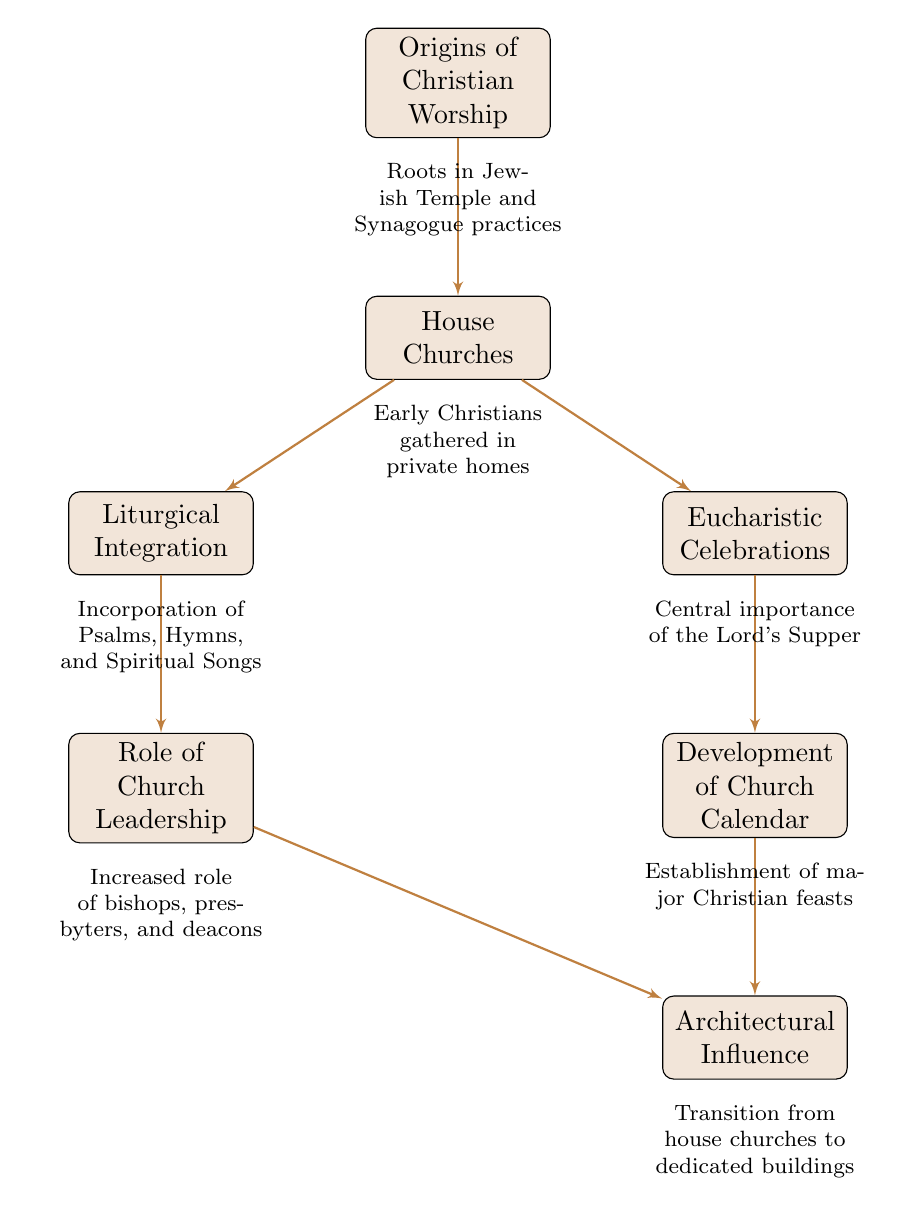What is the first node in the flow chart? The first node in the flow chart is "Origins of Christian Worship". It is the starting point that introduces the roots of Christian liturgical practices.
Answer: Origins of Christian Worship How many nodes are in the diagram? The diagram contains seven nodes, each representing a significant development in early Christian liturgical practices.
Answer: 7 What is the relationship between "House Churches" and "Eucharistic Celebrations"? "House Churches" connects to "Eucharistic Celebrations" indicating that the gatherings in private homes facilitated the practice of Eucharistic celebrations as a central part of worship.
Answer: House Churches → Eucharistic Celebrations What concept is depicted below "Liturgical Integration"? Below "Liturgical Integration" is "Role of Church Leadership". This indicates that the incorporation of various forms of worship was closely related to the growing influence of church leaders in liturgical practices.
Answer: Role of Church Leadership What was established as a result of the "Development of Church Calendar"? The establishment of major Christian feasts like Easter and Pentecost is a direct result of developing a church calendar. This highlights the organization of worship throughout the year.
Answer: Establishment of major Christian feasts Which node follows "Eucharistic Celebrations"? The node that follows "Eucharistic Celebrations" is "Development of Church Calendar". This suggests that celebrating the Eucharist set the foundation for establishing a calendar of church observances.
Answer: Development of Church Calendar How does "Architectural Influence" relate to "House Churches"? "Architectural Influence" is connected to "House Churches" through the evolutionary transition from informal worship settings in homes to dedicated worship buildings, showing the growth and institutionalization of early Christian worship.
Answer: Transition from house churches to dedicated buildings 